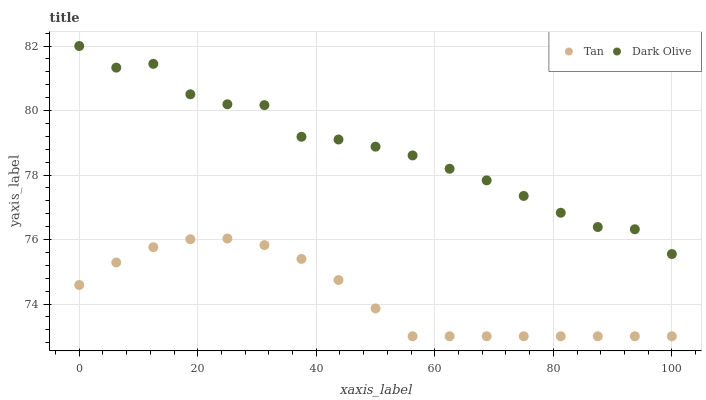Does Tan have the minimum area under the curve?
Answer yes or no. Yes. Does Dark Olive have the maximum area under the curve?
Answer yes or no. Yes. Does Dark Olive have the minimum area under the curve?
Answer yes or no. No. Is Tan the smoothest?
Answer yes or no. Yes. Is Dark Olive the roughest?
Answer yes or no. Yes. Is Dark Olive the smoothest?
Answer yes or no. No. Does Tan have the lowest value?
Answer yes or no. Yes. Does Dark Olive have the lowest value?
Answer yes or no. No. Does Dark Olive have the highest value?
Answer yes or no. Yes. Is Tan less than Dark Olive?
Answer yes or no. Yes. Is Dark Olive greater than Tan?
Answer yes or no. Yes. Does Tan intersect Dark Olive?
Answer yes or no. No. 